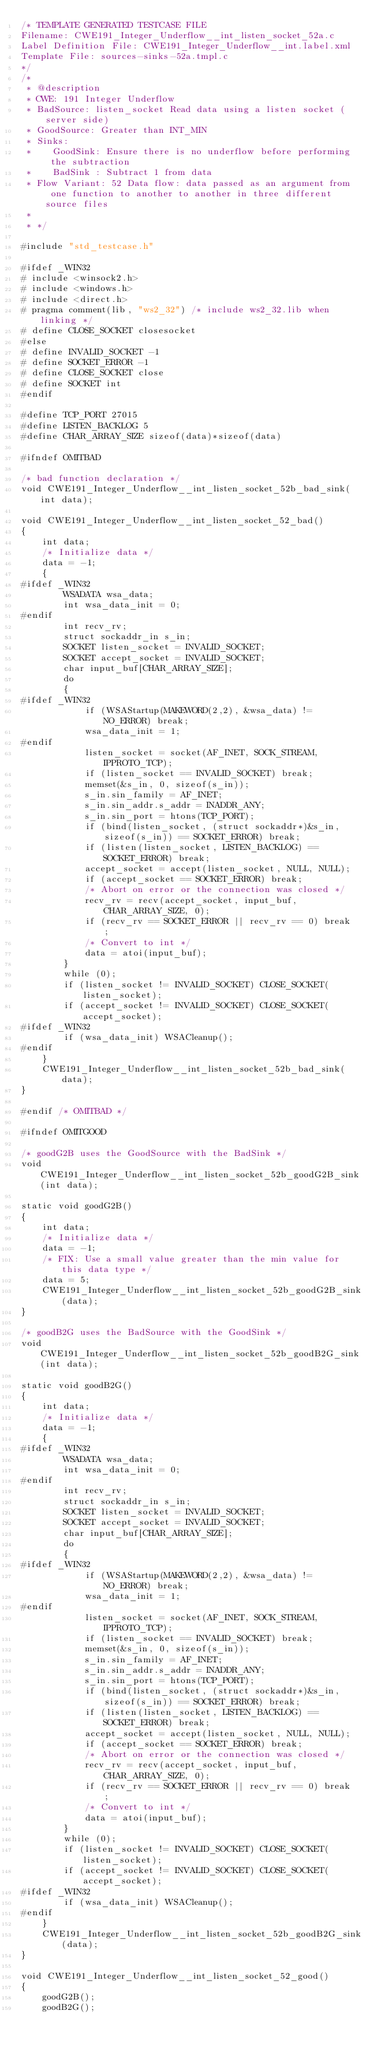Convert code to text. <code><loc_0><loc_0><loc_500><loc_500><_C_>/* TEMPLATE GENERATED TESTCASE FILE
Filename: CWE191_Integer_Underflow__int_listen_socket_52a.c
Label Definition File: CWE191_Integer_Underflow__int.label.xml
Template File: sources-sinks-52a.tmpl.c
*/
/*
 * @description
 * CWE: 191 Integer Underflow
 * BadSource: listen_socket Read data using a listen socket (server side)
 * GoodSource: Greater than INT_MIN
 * Sinks:
 *    GoodSink: Ensure there is no underflow before performing the subtraction
 *    BadSink : Subtract 1 from data
 * Flow Variant: 52 Data flow: data passed as an argument from one function to another to another in three different source files
 *
 * */

#include "std_testcase.h"

#ifdef _WIN32
# include <winsock2.h>
# include <windows.h>
# include <direct.h>
# pragma comment(lib, "ws2_32") /* include ws2_32.lib when linking */
# define CLOSE_SOCKET closesocket
#else
# define INVALID_SOCKET -1
# define SOCKET_ERROR -1
# define CLOSE_SOCKET close
# define SOCKET int
#endif

#define TCP_PORT 27015
#define LISTEN_BACKLOG 5
#define CHAR_ARRAY_SIZE sizeof(data)*sizeof(data)

#ifndef OMITBAD

/* bad function declaration */
void CWE191_Integer_Underflow__int_listen_socket_52b_bad_sink(int data);

void CWE191_Integer_Underflow__int_listen_socket_52_bad()
{
    int data;
    /* Initialize data */
    data = -1;
    {
#ifdef _WIN32
        WSADATA wsa_data;
        int wsa_data_init = 0;
#endif
        int recv_rv;
        struct sockaddr_in s_in;
        SOCKET listen_socket = INVALID_SOCKET;
        SOCKET accept_socket = INVALID_SOCKET;
        char input_buf[CHAR_ARRAY_SIZE];
        do
        {
#ifdef _WIN32
            if (WSAStartup(MAKEWORD(2,2), &wsa_data) != NO_ERROR) break;
            wsa_data_init = 1;
#endif
            listen_socket = socket(AF_INET, SOCK_STREAM, IPPROTO_TCP);
            if (listen_socket == INVALID_SOCKET) break;
            memset(&s_in, 0, sizeof(s_in));
            s_in.sin_family = AF_INET;
            s_in.sin_addr.s_addr = INADDR_ANY;
            s_in.sin_port = htons(TCP_PORT);
            if (bind(listen_socket, (struct sockaddr*)&s_in, sizeof(s_in)) == SOCKET_ERROR) break;
            if (listen(listen_socket, LISTEN_BACKLOG) == SOCKET_ERROR) break;
            accept_socket = accept(listen_socket, NULL, NULL);
            if (accept_socket == SOCKET_ERROR) break;
            /* Abort on error or the connection was closed */
            recv_rv = recv(accept_socket, input_buf, CHAR_ARRAY_SIZE, 0);
            if (recv_rv == SOCKET_ERROR || recv_rv == 0) break;
            /* Convert to int */
            data = atoi(input_buf);
        }
        while (0);
        if (listen_socket != INVALID_SOCKET) CLOSE_SOCKET(listen_socket);
        if (accept_socket != INVALID_SOCKET) CLOSE_SOCKET(accept_socket);
#ifdef _WIN32
        if (wsa_data_init) WSACleanup();
#endif
    }
    CWE191_Integer_Underflow__int_listen_socket_52b_bad_sink(data);
}

#endif /* OMITBAD */

#ifndef OMITGOOD

/* goodG2B uses the GoodSource with the BadSink */
void CWE191_Integer_Underflow__int_listen_socket_52b_goodG2B_sink(int data);

static void goodG2B()
{
    int data;
    /* Initialize data */
    data = -1;
    /* FIX: Use a small value greater than the min value for this data type */
    data = 5;
    CWE191_Integer_Underflow__int_listen_socket_52b_goodG2B_sink(data);
}

/* goodB2G uses the BadSource with the GoodSink */
void CWE191_Integer_Underflow__int_listen_socket_52b_goodB2G_sink(int data);

static void goodB2G()
{
    int data;
    /* Initialize data */
    data = -1;
    {
#ifdef _WIN32
        WSADATA wsa_data;
        int wsa_data_init = 0;
#endif
        int recv_rv;
        struct sockaddr_in s_in;
        SOCKET listen_socket = INVALID_SOCKET;
        SOCKET accept_socket = INVALID_SOCKET;
        char input_buf[CHAR_ARRAY_SIZE];
        do
        {
#ifdef _WIN32
            if (WSAStartup(MAKEWORD(2,2), &wsa_data) != NO_ERROR) break;
            wsa_data_init = 1;
#endif
            listen_socket = socket(AF_INET, SOCK_STREAM, IPPROTO_TCP);
            if (listen_socket == INVALID_SOCKET) break;
            memset(&s_in, 0, sizeof(s_in));
            s_in.sin_family = AF_INET;
            s_in.sin_addr.s_addr = INADDR_ANY;
            s_in.sin_port = htons(TCP_PORT);
            if (bind(listen_socket, (struct sockaddr*)&s_in, sizeof(s_in)) == SOCKET_ERROR) break;
            if (listen(listen_socket, LISTEN_BACKLOG) == SOCKET_ERROR) break;
            accept_socket = accept(listen_socket, NULL, NULL);
            if (accept_socket == SOCKET_ERROR) break;
            /* Abort on error or the connection was closed */
            recv_rv = recv(accept_socket, input_buf, CHAR_ARRAY_SIZE, 0);
            if (recv_rv == SOCKET_ERROR || recv_rv == 0) break;
            /* Convert to int */
            data = atoi(input_buf);
        }
        while (0);
        if (listen_socket != INVALID_SOCKET) CLOSE_SOCKET(listen_socket);
        if (accept_socket != INVALID_SOCKET) CLOSE_SOCKET(accept_socket);
#ifdef _WIN32
        if (wsa_data_init) WSACleanup();
#endif
    }
    CWE191_Integer_Underflow__int_listen_socket_52b_goodB2G_sink(data);
}

void CWE191_Integer_Underflow__int_listen_socket_52_good()
{
    goodG2B();
    goodB2G();</code> 